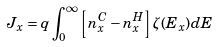Convert formula to latex. <formula><loc_0><loc_0><loc_500><loc_500>J _ { x } = q \int ^ { \infty } _ { 0 } \left [ n ^ { C } _ { x } - n ^ { H } _ { x } \right ] \zeta ( E _ { x } ) d E</formula> 